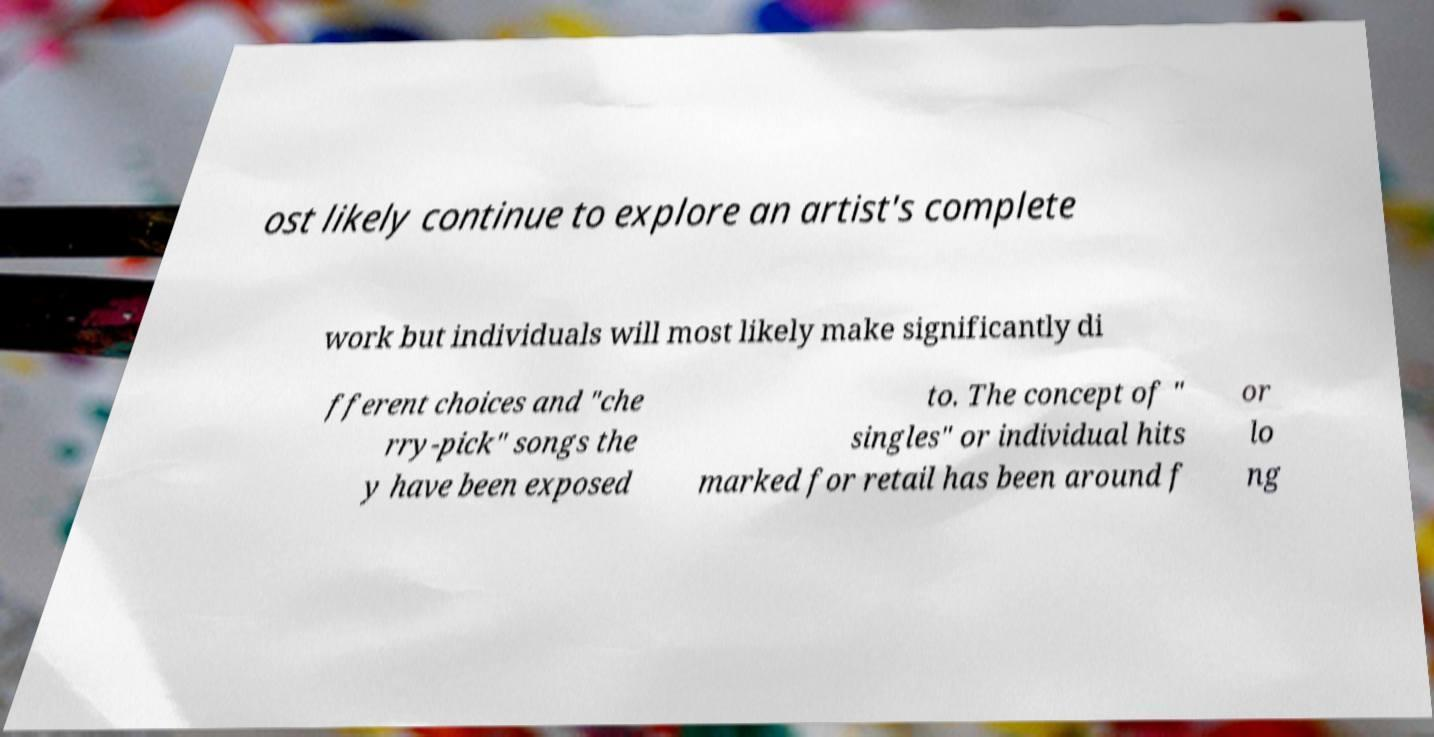Can you accurately transcribe the text from the provided image for me? ost likely continue to explore an artist's complete work but individuals will most likely make significantly di fferent choices and "che rry-pick" songs the y have been exposed to. The concept of " singles" or individual hits marked for retail has been around f or lo ng 